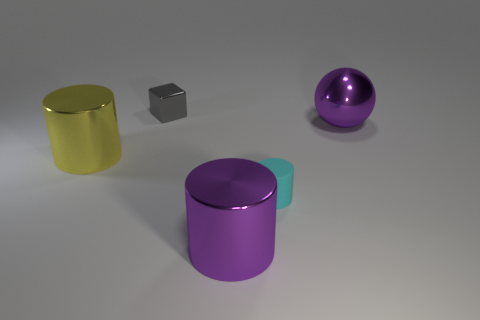Are there any other things that have the same material as the tiny cyan cylinder?
Provide a short and direct response. No. There is a cyan thing that is the same shape as the yellow thing; what size is it?
Offer a terse response. Small. Is the number of tiny blocks that are in front of the yellow shiny thing less than the number of large purple shiny balls?
Provide a short and direct response. Yes. Is the gray object the same shape as the small cyan matte thing?
Offer a very short reply. No. There is a tiny rubber object that is the same shape as the big yellow metallic object; what is its color?
Ensure brevity in your answer.  Cyan. What number of metal things have the same color as the ball?
Your response must be concise. 1. How many objects are metallic objects that are to the left of the small cylinder or gray metallic things?
Offer a very short reply. 3. How big is the shiny cylinder to the left of the large purple metallic cylinder?
Your answer should be compact. Large. Is the number of tiny rubber cylinders less than the number of blue matte spheres?
Your answer should be very brief. No. Is the material of the small object that is behind the large metal ball the same as the purple thing behind the cyan rubber cylinder?
Offer a very short reply. Yes. 